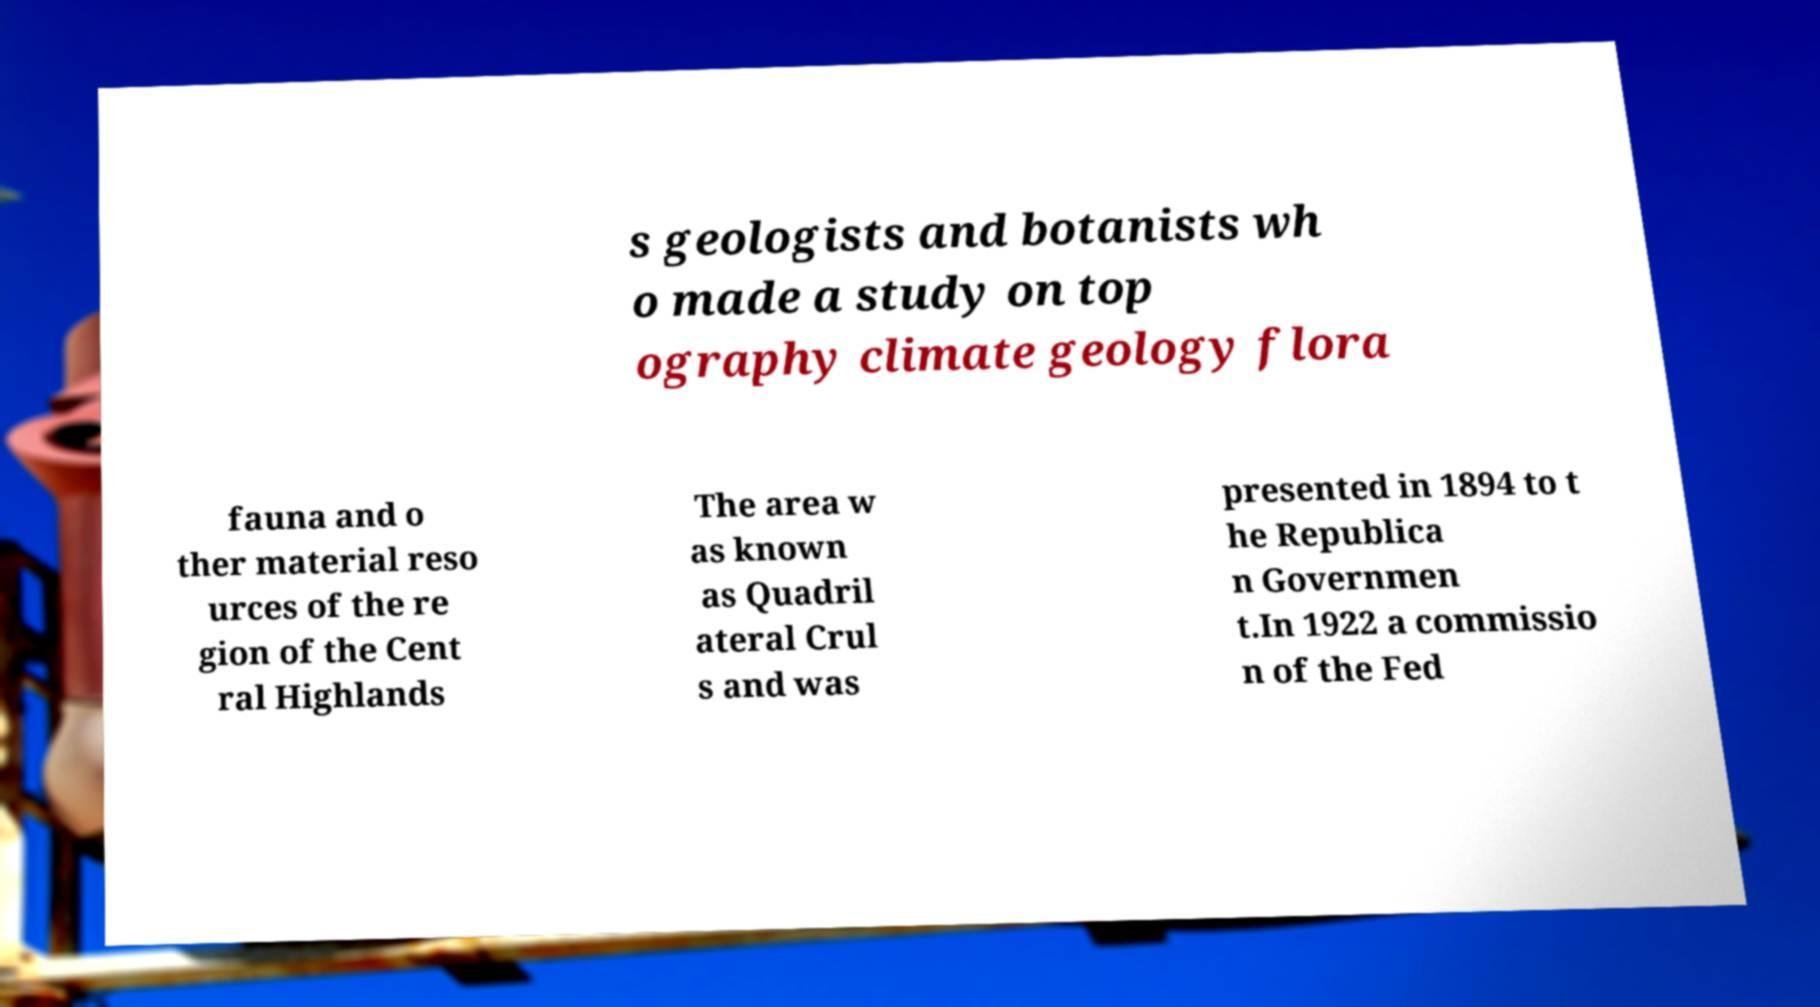There's text embedded in this image that I need extracted. Can you transcribe it verbatim? s geologists and botanists wh o made a study on top ography climate geology flora fauna and o ther material reso urces of the re gion of the Cent ral Highlands The area w as known as Quadril ateral Crul s and was presented in 1894 to t he Republica n Governmen t.In 1922 a commissio n of the Fed 